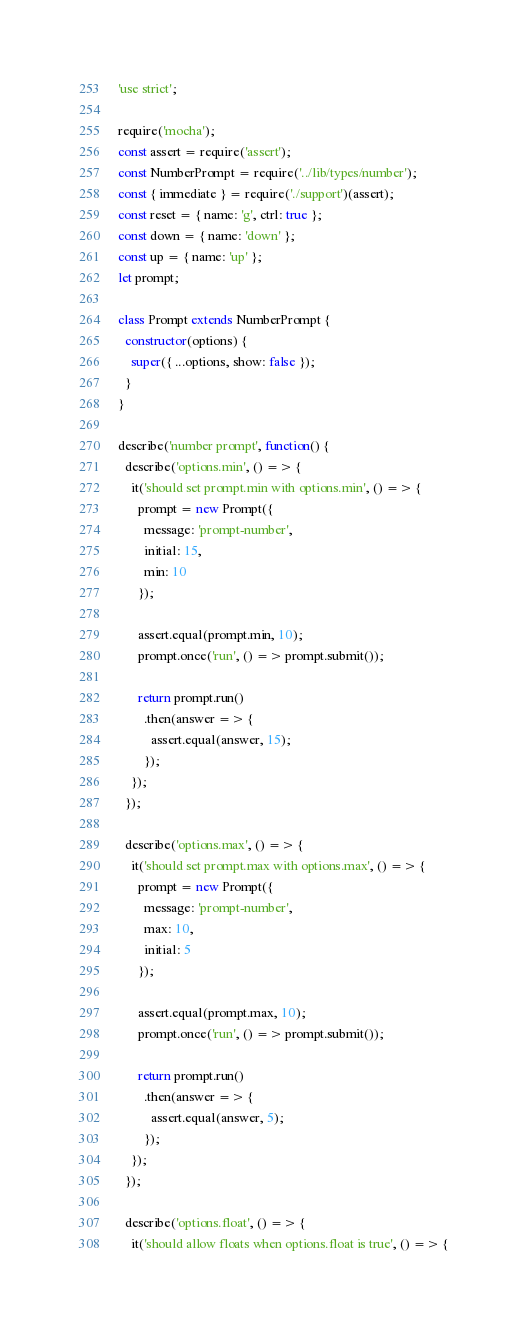Convert code to text. <code><loc_0><loc_0><loc_500><loc_500><_JavaScript_>'use strict';

require('mocha');
const assert = require('assert');
const NumberPrompt = require('../lib/types/number');
const { immediate } = require('./support')(assert);
const reset = { name: 'g', ctrl: true };
const down = { name: 'down' };
const up = { name: 'up' };
let prompt;

class Prompt extends NumberPrompt {
  constructor(options) {
    super({ ...options, show: false });
  }
}

describe('number prompt', function() {
  describe('options.min', () => {
    it('should set prompt.min with options.min', () => {
      prompt = new Prompt({
        message: 'prompt-number',
        initial: 15,
        min: 10
      });

      assert.equal(prompt.min, 10);
      prompt.once('run', () => prompt.submit());

      return prompt.run()
        .then(answer => {
          assert.equal(answer, 15);
        });
    });
  });

  describe('options.max', () => {
    it('should set prompt.max with options.max', () => {
      prompt = new Prompt({
        message: 'prompt-number',
        max: 10,
        initial: 5
      });

      assert.equal(prompt.max, 10);
      prompt.once('run', () => prompt.submit());

      return prompt.run()
        .then(answer => {
          assert.equal(answer, 5);
        });
    });
  });

  describe('options.float', () => {
    it('should allow floats when options.float is true', () => {</code> 